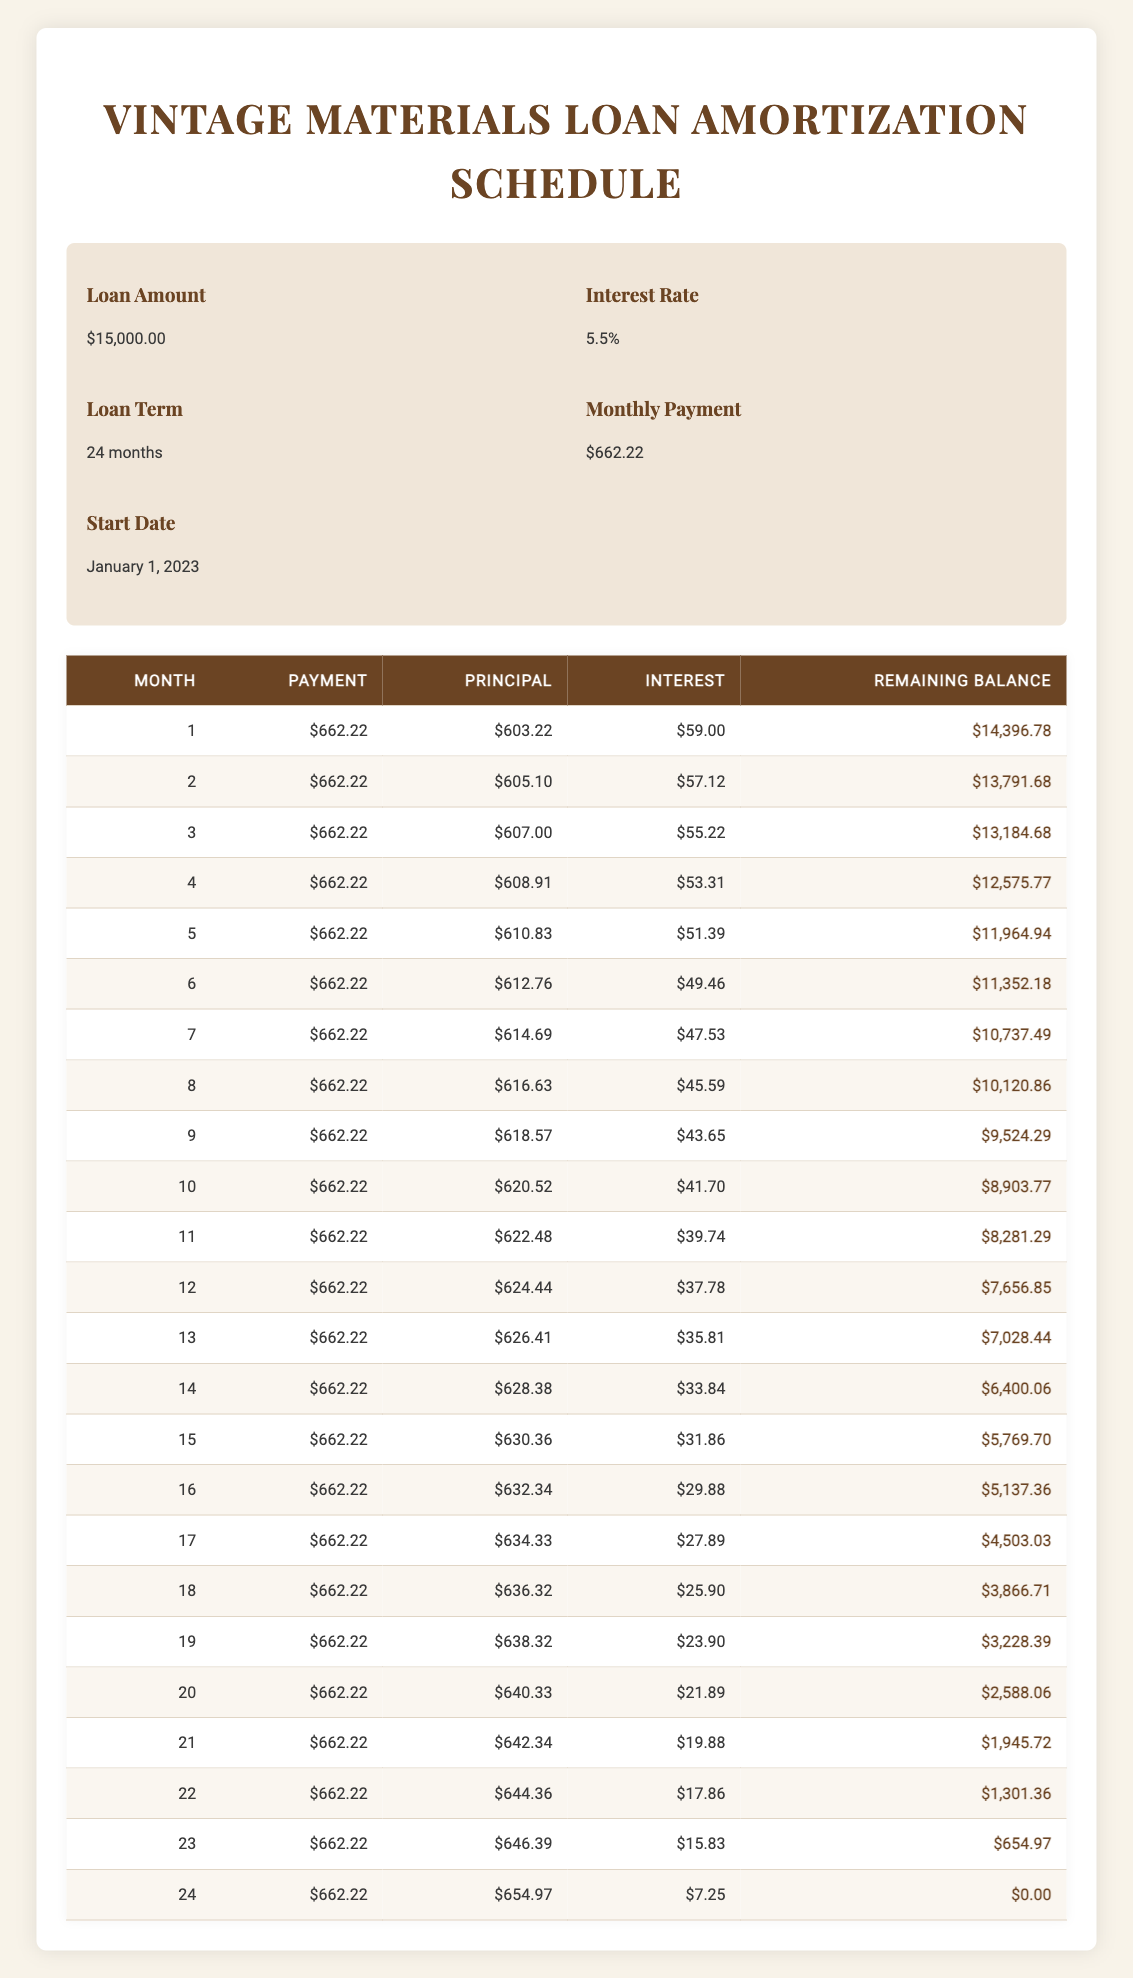What is the total loan amount taken? The table indicates the loan amount in the loan details section. The loan amount is explicitly listed as 15,000.00, without any calculation needed.
Answer: 15000.00 What will be the remaining balance after the first month? The remaining balance after the first month can be found directly in the first payment row of the table. It states the remaining balance as 14,396.78.
Answer: 14396.78 How much of the loan is paid off by the end of the 24th month? To determine how much of the loan is paid off, we subtract the remaining balance after the 24th month (0.00) from the initial loan amount (15,000.00). Thus, the total paid off is 15,000.00 - 0.00 = 15,000.00.
Answer: 15000.00 What is the average principal payment per month? The principal payments for all 24 months need to be summed up. The monthly principal payments listed in the table are summed to find the total principal paid, which is 14,908.19. To find the average, divide this total by 24 months: 14,908.19 / 24 = 620.34.
Answer: 620.34 Is the monthly payment the same for all 24 months? Each payment row in the table shows the same payment amount of 662.22. Therefore, it can be concluded that the monthly payment remains unchanged throughout the loan term.
Answer: Yes What month has the highest interest payment? By reviewing the interest payments listed in each month, the 1st month shows an interest payment of 59.00, while subsequent months show decreasing values. Hence, the 1st month has the highest interest payment.
Answer: 1 What is the total interest paid over the entire loan term? The total interest can be calculated by summing all monthly interest payments from the table. By doing so, the total interest paid equals 368.95.
Answer: 368.95 How much did the principal payment increase from the first month to the last month? To find this, subtract the principal payment of the first month (603.22) from the principal payment of the last month (654.97): 654.97 - 603.22 = 51.75.
Answer: 51.75 In which month did the remaining balance drop below 5,000? Reviewing the remaining balances from each month, the remaining balance falls below 5,000 after the 15th month (5,769.70). Therefore, the 16th month is the first month where the remaining balance is below 5,000.
Answer: 16 